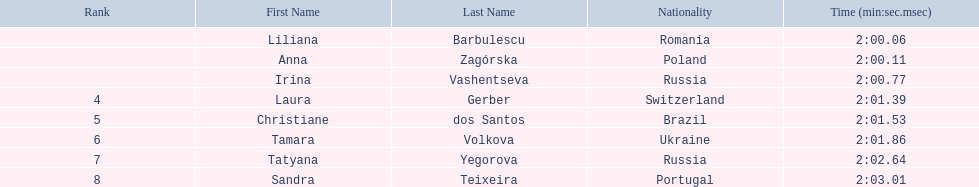Which athletes competed in the 2003 summer universiade - women's 800 metres? Liliana Barbulescu, Anna Zagórska, Irina Vashentseva, Laura Gerber, Christiane dos Santos, Tamara Volkova, Tatyana Yegorova, Sandra Teixeira. Of these, which are from poland? Anna Zagórska. What is her time? 2:00.11. 